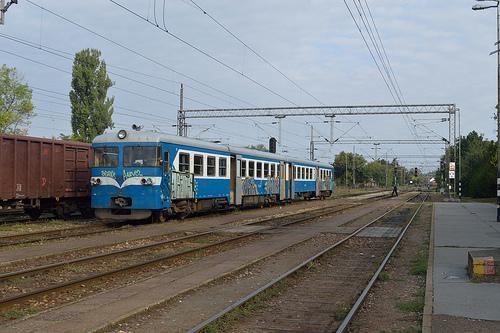How many carriages are on the blue train?
Give a very brief answer. 4. How many empty tracks are in the picture?
Give a very brief answer. 2. 